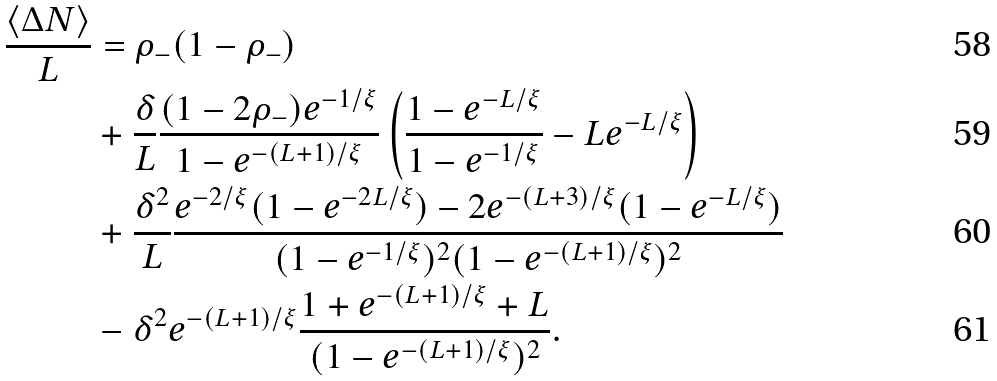<formula> <loc_0><loc_0><loc_500><loc_500>\frac { \langle \Delta N \rangle } { L } & = \rho _ { - } ( 1 - \rho _ { - } ) \\ & + \frac { \delta } { L } \frac { ( 1 - 2 \rho _ { - } ) e ^ { - 1 / \xi } } { 1 - e ^ { - ( L + 1 ) / \xi } } \left ( \frac { 1 - e ^ { - L / \xi } } { 1 - e ^ { - 1 / \xi } } - L e ^ { - L / \xi } \right ) \\ & + \frac { \delta ^ { 2 } } { L } \frac { e ^ { - 2 / \xi } ( 1 - e ^ { - 2 L / \xi } ) - 2 e ^ { - ( L + 3 ) / \xi } ( 1 - e ^ { - L / \xi } ) } { ( 1 - e ^ { - 1 / \xi } ) ^ { 2 } ( 1 - e ^ { - ( L + 1 ) / \xi } ) ^ { 2 } } \\ & - \delta ^ { 2 } e ^ { - ( L + 1 ) / \xi } \frac { 1 + e ^ { - ( L + 1 ) / \xi } + L } { ( 1 - e ^ { - ( L + 1 ) / \xi } ) ^ { 2 } } .</formula> 